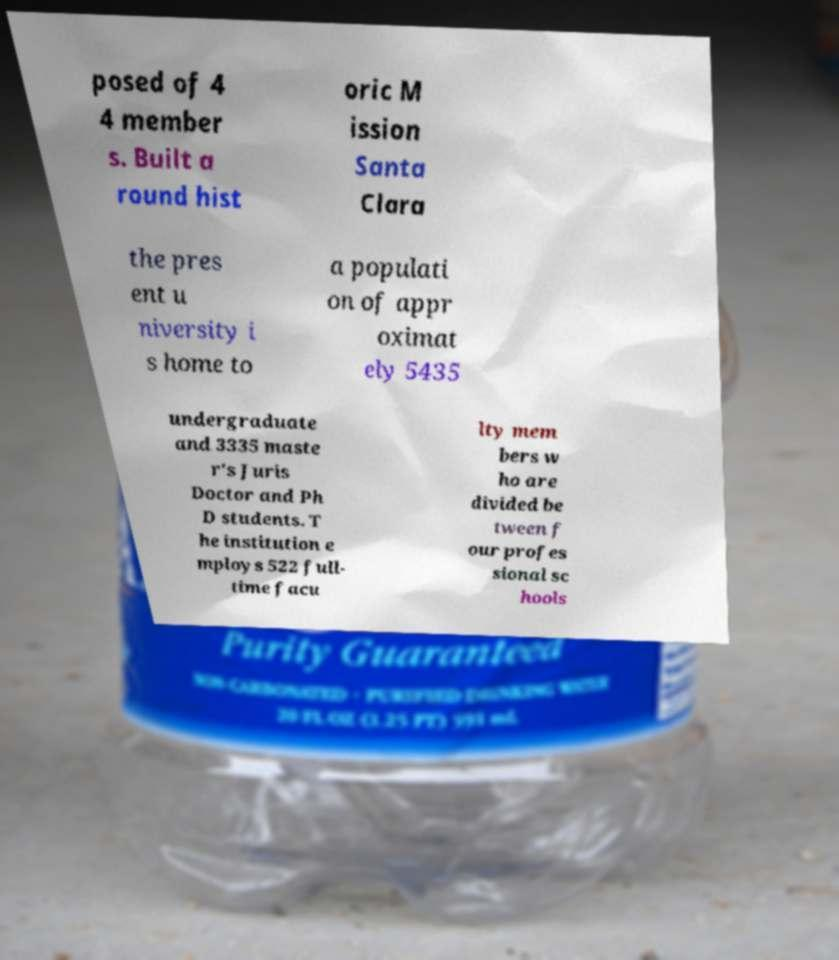Can you accurately transcribe the text from the provided image for me? posed of 4 4 member s. Built a round hist oric M ission Santa Clara the pres ent u niversity i s home to a populati on of appr oximat ely 5435 undergraduate and 3335 maste r's Juris Doctor and Ph D students. T he institution e mploys 522 full- time facu lty mem bers w ho are divided be tween f our profes sional sc hools 